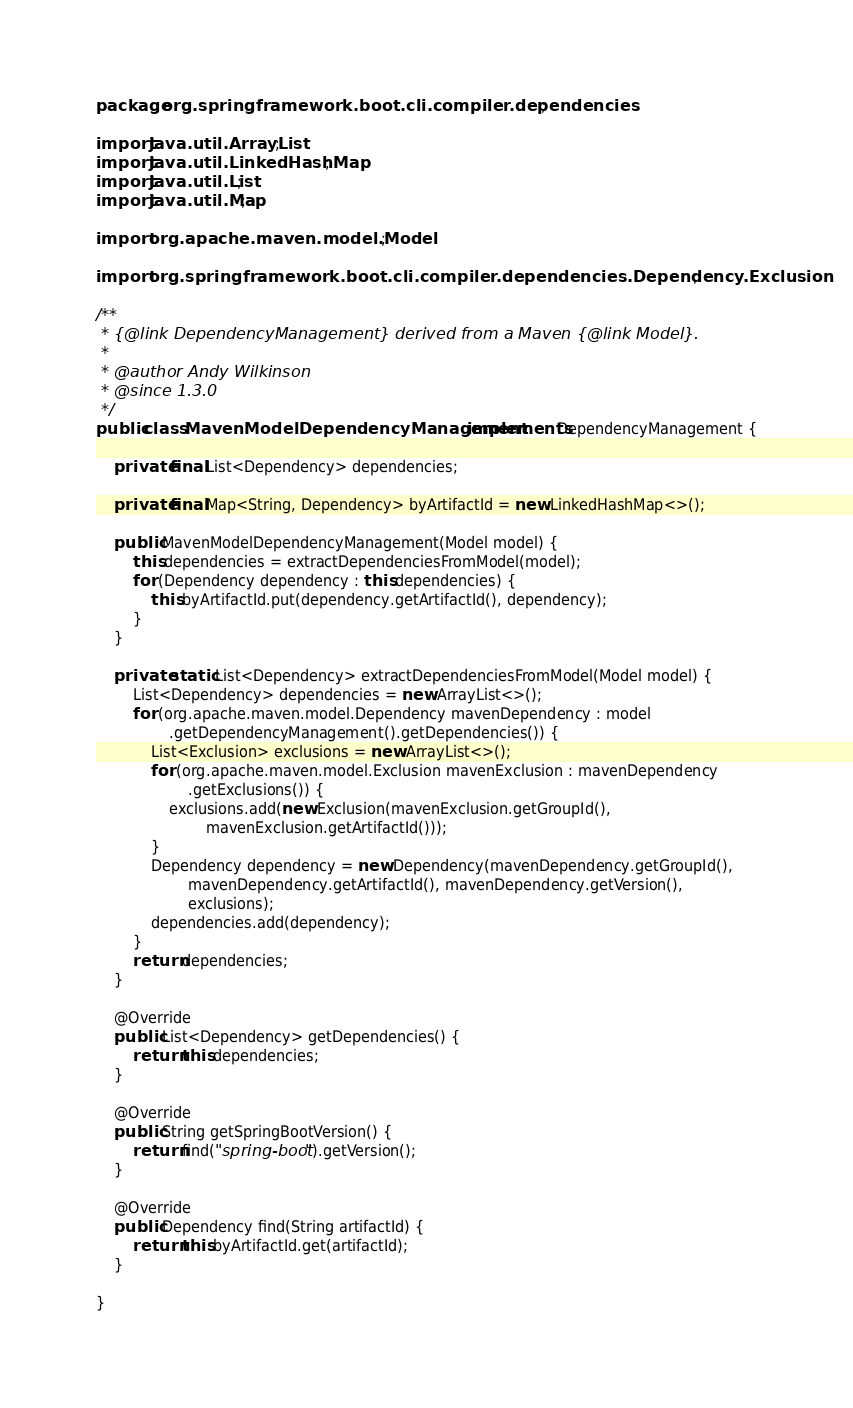Convert code to text. <code><loc_0><loc_0><loc_500><loc_500><_Java_>

package org.springframework.boot.cli.compiler.dependencies;

import java.util.ArrayList;
import java.util.LinkedHashMap;
import java.util.List;
import java.util.Map;

import org.apache.maven.model.Model;

import org.springframework.boot.cli.compiler.dependencies.Dependency.Exclusion;

/**
 * {@link DependencyManagement} derived from a Maven {@link Model}.
 *
 * @author Andy Wilkinson
 * @since 1.3.0
 */
public class MavenModelDependencyManagement implements DependencyManagement {

	private final List<Dependency> dependencies;

	private final Map<String, Dependency> byArtifactId = new LinkedHashMap<>();

	public MavenModelDependencyManagement(Model model) {
		this.dependencies = extractDependenciesFromModel(model);
		for (Dependency dependency : this.dependencies) {
			this.byArtifactId.put(dependency.getArtifactId(), dependency);
		}
	}

	private static List<Dependency> extractDependenciesFromModel(Model model) {
		List<Dependency> dependencies = new ArrayList<>();
		for (org.apache.maven.model.Dependency mavenDependency : model
				.getDependencyManagement().getDependencies()) {
			List<Exclusion> exclusions = new ArrayList<>();
			for (org.apache.maven.model.Exclusion mavenExclusion : mavenDependency
					.getExclusions()) {
				exclusions.add(new Exclusion(mavenExclusion.getGroupId(),
						mavenExclusion.getArtifactId()));
			}
			Dependency dependency = new Dependency(mavenDependency.getGroupId(),
					mavenDependency.getArtifactId(), mavenDependency.getVersion(),
					exclusions);
			dependencies.add(dependency);
		}
		return dependencies;
	}

	@Override
	public List<Dependency> getDependencies() {
		return this.dependencies;
	}

	@Override
	public String getSpringBootVersion() {
		return find("spring-boot").getVersion();
	}

	@Override
	public Dependency find(String artifactId) {
		return this.byArtifactId.get(artifactId);
	}

}
</code> 